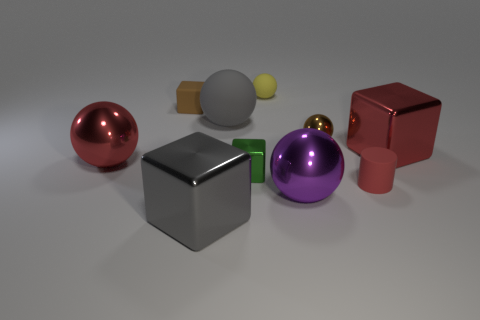Subtract 1 blocks. How many blocks are left? 3 Subtract all yellow balls. How many balls are left? 4 Subtract all large rubber spheres. How many spheres are left? 4 Subtract all cyan balls. Subtract all red cubes. How many balls are left? 5 Subtract all cylinders. How many objects are left? 9 Add 6 big purple things. How many big purple things exist? 7 Subtract 0 cyan balls. How many objects are left? 10 Subtract all tiny gray metallic blocks. Subtract all tiny green cubes. How many objects are left? 9 Add 2 shiny blocks. How many shiny blocks are left? 5 